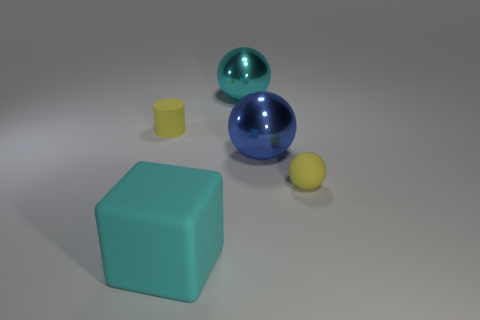Can you tell me what the large blue object is made of, and how it differs from the small yellow ball? The large blue object seems to be made of a glass-like material due to its transparent and reflective characteristics. It differs from the small yellow ball, which looks to be made of a solid, matte material, likely plastic. 